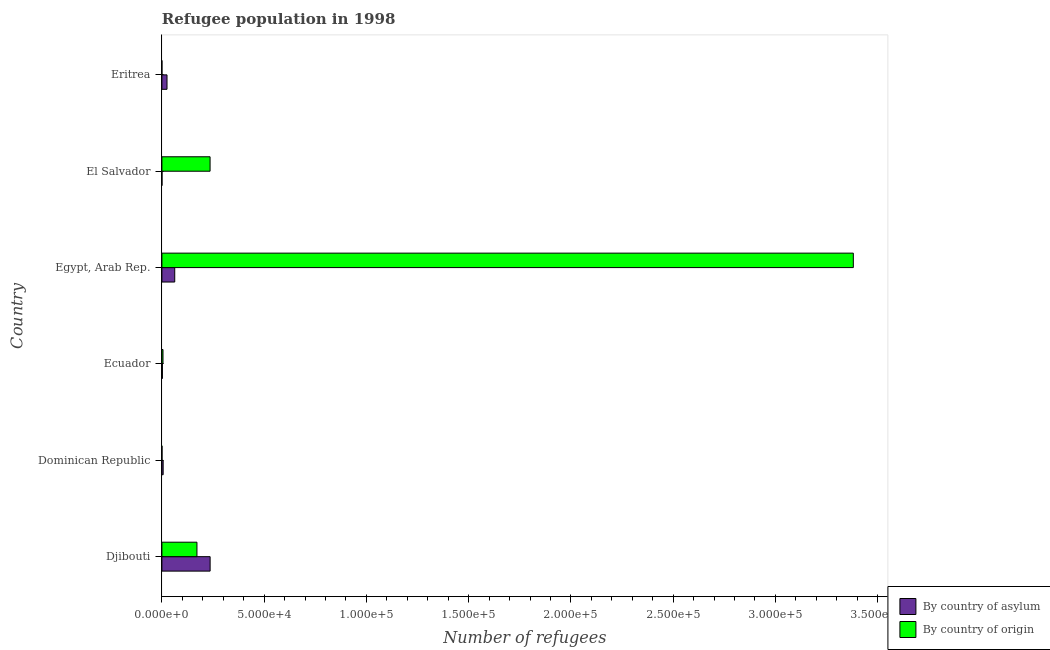How many groups of bars are there?
Your answer should be compact. 6. Are the number of bars on each tick of the Y-axis equal?
Give a very brief answer. Yes. What is the label of the 4th group of bars from the top?
Your answer should be compact. Ecuador. In how many cases, is the number of bars for a given country not equal to the number of legend labels?
Your answer should be compact. 0. What is the number of refugees by country of asylum in Dominican Republic?
Your answer should be very brief. 614. Across all countries, what is the maximum number of refugees by country of origin?
Ensure brevity in your answer.  3.38e+05. Across all countries, what is the minimum number of refugees by country of asylum?
Offer a terse response. 33. In which country was the number of refugees by country of origin maximum?
Keep it short and to the point. Egypt, Arab Rep. In which country was the number of refugees by country of asylum minimum?
Ensure brevity in your answer.  El Salvador. What is the total number of refugees by country of origin in the graph?
Make the answer very short. 3.79e+05. What is the difference between the number of refugees by country of origin in Ecuador and that in El Salvador?
Your answer should be very brief. -2.30e+04. What is the difference between the number of refugees by country of origin in Eritrea and the number of refugees by country of asylum in Egypt, Arab Rep.?
Provide a short and direct response. -6265. What is the average number of refugees by country of origin per country?
Make the answer very short. 6.32e+04. What is the difference between the number of refugees by country of asylum and number of refugees by country of origin in Djibouti?
Your answer should be compact. 6439. In how many countries, is the number of refugees by country of origin greater than 90000 ?
Provide a succinct answer. 1. What is the ratio of the number of refugees by country of origin in Egypt, Arab Rep. to that in El Salvador?
Provide a succinct answer. 14.35. Is the number of refugees by country of asylum in Dominican Republic less than that in Eritrea?
Your answer should be compact. Yes. What is the difference between the highest and the second highest number of refugees by country of origin?
Your answer should be compact. 3.15e+05. What is the difference between the highest and the lowest number of refugees by country of origin?
Keep it short and to the point. 3.38e+05. Is the sum of the number of refugees by country of origin in Ecuador and Eritrea greater than the maximum number of refugees by country of asylum across all countries?
Your response must be concise. No. What does the 1st bar from the top in Egypt, Arab Rep. represents?
Your response must be concise. By country of origin. What does the 2nd bar from the bottom in Dominican Republic represents?
Offer a terse response. By country of origin. How many countries are there in the graph?
Offer a terse response. 6. Are the values on the major ticks of X-axis written in scientific E-notation?
Ensure brevity in your answer.  Yes. Does the graph contain grids?
Your response must be concise. No. How are the legend labels stacked?
Keep it short and to the point. Vertical. What is the title of the graph?
Ensure brevity in your answer.  Refugee population in 1998. Does "Lowest 10% of population" appear as one of the legend labels in the graph?
Provide a short and direct response. No. What is the label or title of the X-axis?
Your answer should be compact. Number of refugees. What is the Number of refugees in By country of asylum in Djibouti?
Give a very brief answer. 2.36e+04. What is the Number of refugees in By country of origin in Djibouti?
Your answer should be very brief. 1.71e+04. What is the Number of refugees of By country of asylum in Dominican Republic?
Make the answer very short. 614. What is the Number of refugees of By country of asylum in Ecuador?
Make the answer very short. 248. What is the Number of refugees of By country of origin in Ecuador?
Your answer should be very brief. 537. What is the Number of refugees in By country of asylum in Egypt, Arab Rep.?
Your response must be concise. 6276. What is the Number of refugees of By country of origin in Egypt, Arab Rep.?
Ensure brevity in your answer.  3.38e+05. What is the Number of refugees in By country of asylum in El Salvador?
Your answer should be very brief. 33. What is the Number of refugees in By country of origin in El Salvador?
Make the answer very short. 2.36e+04. What is the Number of refugees of By country of asylum in Eritrea?
Make the answer very short. 2501. Across all countries, what is the maximum Number of refugees of By country of asylum?
Provide a short and direct response. 2.36e+04. Across all countries, what is the maximum Number of refugees in By country of origin?
Provide a succinct answer. 3.38e+05. What is the total Number of refugees of By country of asylum in the graph?
Your answer should be compact. 3.33e+04. What is the total Number of refugees of By country of origin in the graph?
Ensure brevity in your answer.  3.79e+05. What is the difference between the Number of refugees in By country of asylum in Djibouti and that in Dominican Republic?
Offer a very short reply. 2.30e+04. What is the difference between the Number of refugees in By country of origin in Djibouti and that in Dominican Republic?
Your answer should be very brief. 1.71e+04. What is the difference between the Number of refugees in By country of asylum in Djibouti and that in Ecuador?
Provide a succinct answer. 2.33e+04. What is the difference between the Number of refugees of By country of origin in Djibouti and that in Ecuador?
Offer a terse response. 1.66e+04. What is the difference between the Number of refugees in By country of asylum in Djibouti and that in Egypt, Arab Rep.?
Your response must be concise. 1.73e+04. What is the difference between the Number of refugees of By country of origin in Djibouti and that in Egypt, Arab Rep.?
Ensure brevity in your answer.  -3.21e+05. What is the difference between the Number of refugees of By country of asylum in Djibouti and that in El Salvador?
Your response must be concise. 2.35e+04. What is the difference between the Number of refugees in By country of origin in Djibouti and that in El Salvador?
Make the answer very short. -6416. What is the difference between the Number of refugees in By country of asylum in Djibouti and that in Eritrea?
Keep it short and to the point. 2.11e+04. What is the difference between the Number of refugees in By country of origin in Djibouti and that in Eritrea?
Your answer should be very brief. 1.71e+04. What is the difference between the Number of refugees in By country of asylum in Dominican Republic and that in Ecuador?
Provide a short and direct response. 366. What is the difference between the Number of refugees of By country of origin in Dominican Republic and that in Ecuador?
Offer a very short reply. -483. What is the difference between the Number of refugees in By country of asylum in Dominican Republic and that in Egypt, Arab Rep.?
Provide a succinct answer. -5662. What is the difference between the Number of refugees of By country of origin in Dominican Republic and that in Egypt, Arab Rep.?
Provide a succinct answer. -3.38e+05. What is the difference between the Number of refugees in By country of asylum in Dominican Republic and that in El Salvador?
Keep it short and to the point. 581. What is the difference between the Number of refugees in By country of origin in Dominican Republic and that in El Salvador?
Your answer should be compact. -2.35e+04. What is the difference between the Number of refugees in By country of asylum in Dominican Republic and that in Eritrea?
Your answer should be very brief. -1887. What is the difference between the Number of refugees of By country of origin in Dominican Republic and that in Eritrea?
Offer a very short reply. 43. What is the difference between the Number of refugees of By country of asylum in Ecuador and that in Egypt, Arab Rep.?
Keep it short and to the point. -6028. What is the difference between the Number of refugees in By country of origin in Ecuador and that in Egypt, Arab Rep.?
Your answer should be very brief. -3.38e+05. What is the difference between the Number of refugees of By country of asylum in Ecuador and that in El Salvador?
Your answer should be compact. 215. What is the difference between the Number of refugees of By country of origin in Ecuador and that in El Salvador?
Provide a short and direct response. -2.30e+04. What is the difference between the Number of refugees in By country of asylum in Ecuador and that in Eritrea?
Keep it short and to the point. -2253. What is the difference between the Number of refugees in By country of origin in Ecuador and that in Eritrea?
Keep it short and to the point. 526. What is the difference between the Number of refugees in By country of asylum in Egypt, Arab Rep. and that in El Salvador?
Your answer should be compact. 6243. What is the difference between the Number of refugees in By country of origin in Egypt, Arab Rep. and that in El Salvador?
Give a very brief answer. 3.15e+05. What is the difference between the Number of refugees of By country of asylum in Egypt, Arab Rep. and that in Eritrea?
Keep it short and to the point. 3775. What is the difference between the Number of refugees of By country of origin in Egypt, Arab Rep. and that in Eritrea?
Ensure brevity in your answer.  3.38e+05. What is the difference between the Number of refugees of By country of asylum in El Salvador and that in Eritrea?
Offer a very short reply. -2468. What is the difference between the Number of refugees in By country of origin in El Salvador and that in Eritrea?
Make the answer very short. 2.35e+04. What is the difference between the Number of refugees in By country of asylum in Djibouti and the Number of refugees in By country of origin in Dominican Republic?
Keep it short and to the point. 2.35e+04. What is the difference between the Number of refugees of By country of asylum in Djibouti and the Number of refugees of By country of origin in Ecuador?
Provide a succinct answer. 2.30e+04. What is the difference between the Number of refugees of By country of asylum in Djibouti and the Number of refugees of By country of origin in Egypt, Arab Rep.?
Ensure brevity in your answer.  -3.15e+05. What is the difference between the Number of refugees in By country of asylum in Djibouti and the Number of refugees in By country of origin in Eritrea?
Provide a succinct answer. 2.36e+04. What is the difference between the Number of refugees in By country of asylum in Dominican Republic and the Number of refugees in By country of origin in Egypt, Arab Rep.?
Your answer should be compact. -3.37e+05. What is the difference between the Number of refugees of By country of asylum in Dominican Republic and the Number of refugees of By country of origin in El Salvador?
Your response must be concise. -2.29e+04. What is the difference between the Number of refugees in By country of asylum in Dominican Republic and the Number of refugees in By country of origin in Eritrea?
Make the answer very short. 603. What is the difference between the Number of refugees of By country of asylum in Ecuador and the Number of refugees of By country of origin in Egypt, Arab Rep.?
Ensure brevity in your answer.  -3.38e+05. What is the difference between the Number of refugees of By country of asylum in Ecuador and the Number of refugees of By country of origin in El Salvador?
Your response must be concise. -2.33e+04. What is the difference between the Number of refugees in By country of asylum in Ecuador and the Number of refugees in By country of origin in Eritrea?
Your response must be concise. 237. What is the difference between the Number of refugees of By country of asylum in Egypt, Arab Rep. and the Number of refugees of By country of origin in El Salvador?
Make the answer very short. -1.73e+04. What is the difference between the Number of refugees in By country of asylum in Egypt, Arab Rep. and the Number of refugees in By country of origin in Eritrea?
Your answer should be very brief. 6265. What is the average Number of refugees of By country of asylum per country?
Your answer should be compact. 5542.33. What is the average Number of refugees of By country of origin per country?
Offer a very short reply. 6.32e+04. What is the difference between the Number of refugees in By country of asylum and Number of refugees in By country of origin in Djibouti?
Ensure brevity in your answer.  6439. What is the difference between the Number of refugees in By country of asylum and Number of refugees in By country of origin in Dominican Republic?
Your answer should be compact. 560. What is the difference between the Number of refugees in By country of asylum and Number of refugees in By country of origin in Ecuador?
Your answer should be compact. -289. What is the difference between the Number of refugees of By country of asylum and Number of refugees of By country of origin in Egypt, Arab Rep.?
Provide a succinct answer. -3.32e+05. What is the difference between the Number of refugees of By country of asylum and Number of refugees of By country of origin in El Salvador?
Offer a terse response. -2.35e+04. What is the difference between the Number of refugees in By country of asylum and Number of refugees in By country of origin in Eritrea?
Keep it short and to the point. 2490. What is the ratio of the Number of refugees of By country of asylum in Djibouti to that in Dominican Republic?
Give a very brief answer. 38.41. What is the ratio of the Number of refugees in By country of origin in Djibouti to that in Dominican Republic?
Make the answer very short. 317.46. What is the ratio of the Number of refugees of By country of asylum in Djibouti to that in Ecuador?
Your response must be concise. 95.09. What is the ratio of the Number of refugees in By country of origin in Djibouti to that in Ecuador?
Your response must be concise. 31.92. What is the ratio of the Number of refugees of By country of asylum in Djibouti to that in Egypt, Arab Rep.?
Make the answer very short. 3.76. What is the ratio of the Number of refugees in By country of origin in Djibouti to that in Egypt, Arab Rep.?
Your answer should be compact. 0.05. What is the ratio of the Number of refugees of By country of asylum in Djibouti to that in El Salvador?
Provide a succinct answer. 714.61. What is the ratio of the Number of refugees of By country of origin in Djibouti to that in El Salvador?
Give a very brief answer. 0.73. What is the ratio of the Number of refugees of By country of asylum in Djibouti to that in Eritrea?
Your answer should be very brief. 9.43. What is the ratio of the Number of refugees in By country of origin in Djibouti to that in Eritrea?
Give a very brief answer. 1558.45. What is the ratio of the Number of refugees of By country of asylum in Dominican Republic to that in Ecuador?
Provide a short and direct response. 2.48. What is the ratio of the Number of refugees of By country of origin in Dominican Republic to that in Ecuador?
Make the answer very short. 0.1. What is the ratio of the Number of refugees in By country of asylum in Dominican Republic to that in Egypt, Arab Rep.?
Make the answer very short. 0.1. What is the ratio of the Number of refugees of By country of asylum in Dominican Republic to that in El Salvador?
Give a very brief answer. 18.61. What is the ratio of the Number of refugees of By country of origin in Dominican Republic to that in El Salvador?
Provide a succinct answer. 0. What is the ratio of the Number of refugees in By country of asylum in Dominican Republic to that in Eritrea?
Make the answer very short. 0.25. What is the ratio of the Number of refugees in By country of origin in Dominican Republic to that in Eritrea?
Ensure brevity in your answer.  4.91. What is the ratio of the Number of refugees in By country of asylum in Ecuador to that in Egypt, Arab Rep.?
Your answer should be compact. 0.04. What is the ratio of the Number of refugees of By country of origin in Ecuador to that in Egypt, Arab Rep.?
Provide a succinct answer. 0. What is the ratio of the Number of refugees in By country of asylum in Ecuador to that in El Salvador?
Offer a terse response. 7.52. What is the ratio of the Number of refugees in By country of origin in Ecuador to that in El Salvador?
Give a very brief answer. 0.02. What is the ratio of the Number of refugees of By country of asylum in Ecuador to that in Eritrea?
Your answer should be very brief. 0.1. What is the ratio of the Number of refugees in By country of origin in Ecuador to that in Eritrea?
Give a very brief answer. 48.82. What is the ratio of the Number of refugees in By country of asylum in Egypt, Arab Rep. to that in El Salvador?
Keep it short and to the point. 190.18. What is the ratio of the Number of refugees of By country of origin in Egypt, Arab Rep. to that in El Salvador?
Offer a terse response. 14.35. What is the ratio of the Number of refugees of By country of asylum in Egypt, Arab Rep. to that in Eritrea?
Your response must be concise. 2.51. What is the ratio of the Number of refugees of By country of origin in Egypt, Arab Rep. to that in Eritrea?
Offer a terse response. 3.07e+04. What is the ratio of the Number of refugees in By country of asylum in El Salvador to that in Eritrea?
Your answer should be compact. 0.01. What is the ratio of the Number of refugees in By country of origin in El Salvador to that in Eritrea?
Keep it short and to the point. 2141.73. What is the difference between the highest and the second highest Number of refugees in By country of asylum?
Keep it short and to the point. 1.73e+04. What is the difference between the highest and the second highest Number of refugees of By country of origin?
Offer a very short reply. 3.15e+05. What is the difference between the highest and the lowest Number of refugees of By country of asylum?
Your response must be concise. 2.35e+04. What is the difference between the highest and the lowest Number of refugees in By country of origin?
Offer a terse response. 3.38e+05. 